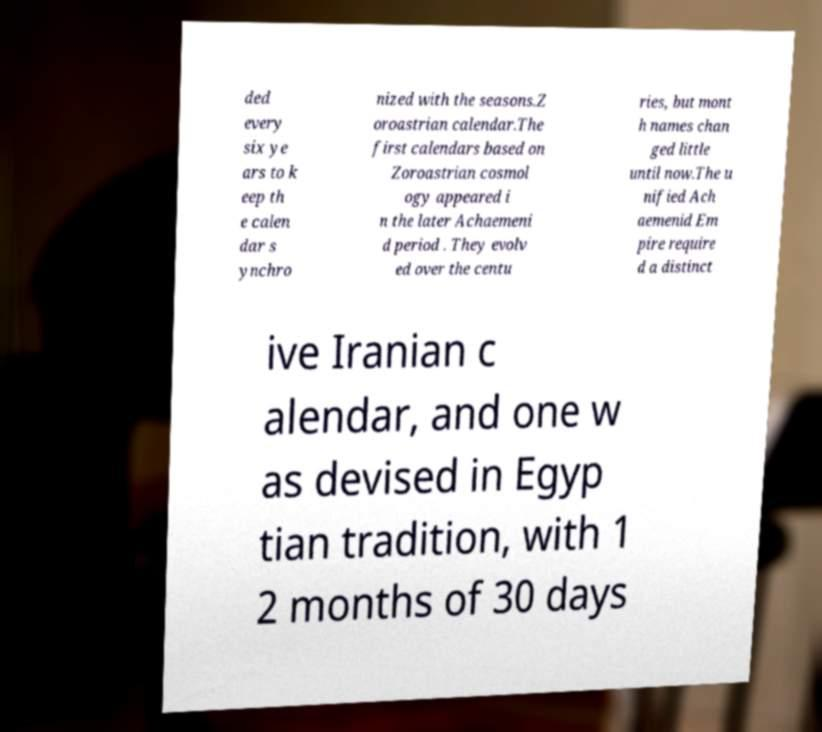Could you extract and type out the text from this image? ded every six ye ars to k eep th e calen dar s ynchro nized with the seasons.Z oroastrian calendar.The first calendars based on Zoroastrian cosmol ogy appeared i n the later Achaemeni d period . They evolv ed over the centu ries, but mont h names chan ged little until now.The u nified Ach aemenid Em pire require d a distinct ive Iranian c alendar, and one w as devised in Egyp tian tradition, with 1 2 months of 30 days 